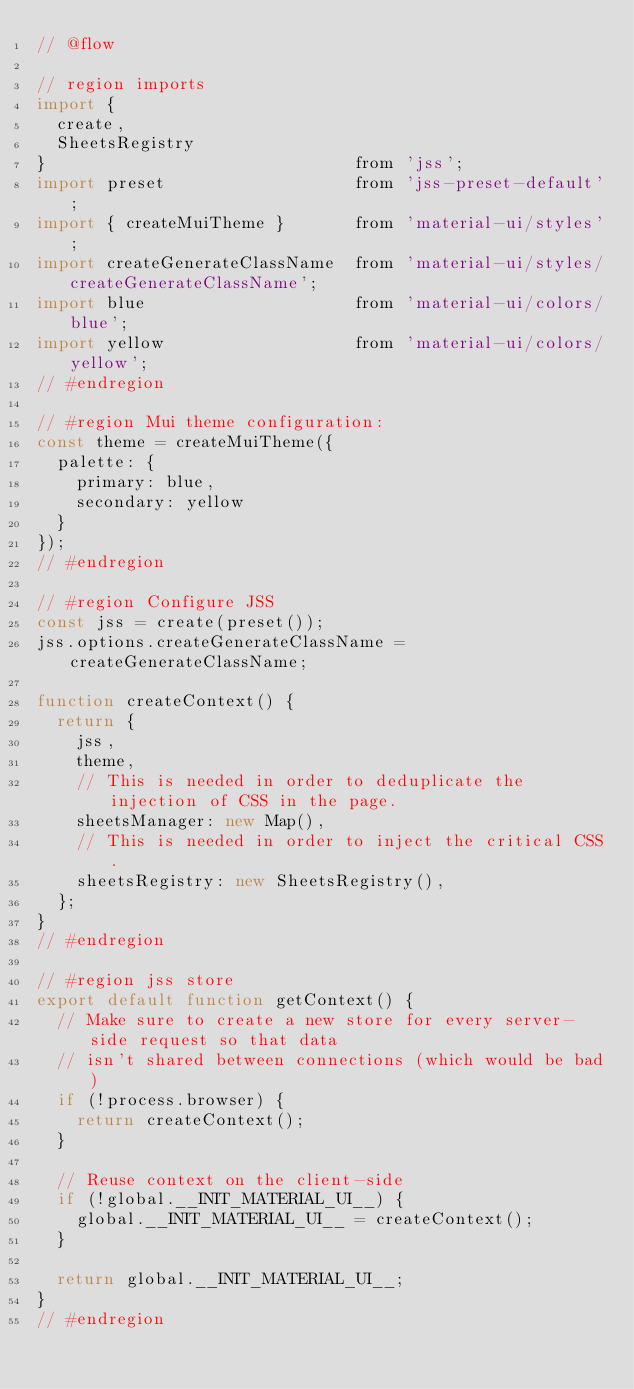Convert code to text. <code><loc_0><loc_0><loc_500><loc_500><_JavaScript_>// @flow

// region imports
import {
  create,
  SheetsRegistry
}                               from 'jss';
import preset                   from 'jss-preset-default';
import { createMuiTheme }       from 'material-ui/styles';
import createGenerateClassName  from 'material-ui/styles/createGenerateClassName';
import blue                     from 'material-ui/colors/blue';
import yellow                   from 'material-ui/colors/yellow';
// #endregion

// #region Mui theme configuration:
const theme = createMuiTheme({
  palette: {
    primary: blue,
    secondary: yellow
  }
});
// #endregion

// #region Configure JSS
const jss = create(preset());
jss.options.createGenerateClassName = createGenerateClassName;

function createContext() {
  return {
    jss,
    theme,
    // This is needed in order to deduplicate the injection of CSS in the page.
    sheetsManager: new Map(),
    // This is needed in order to inject the critical CSS.
    sheetsRegistry: new SheetsRegistry(),
  };
}
// #endregion

// #region jss store
export default function getContext() {
  // Make sure to create a new store for every server-side request so that data
  // isn't shared between connections (which would be bad)
  if (!process.browser) {
    return createContext();
  }

  // Reuse context on the client-side
  if (!global.__INIT_MATERIAL_UI__) {
    global.__INIT_MATERIAL_UI__ = createContext();
  }

  return global.__INIT_MATERIAL_UI__;
}
// #endregion
</code> 